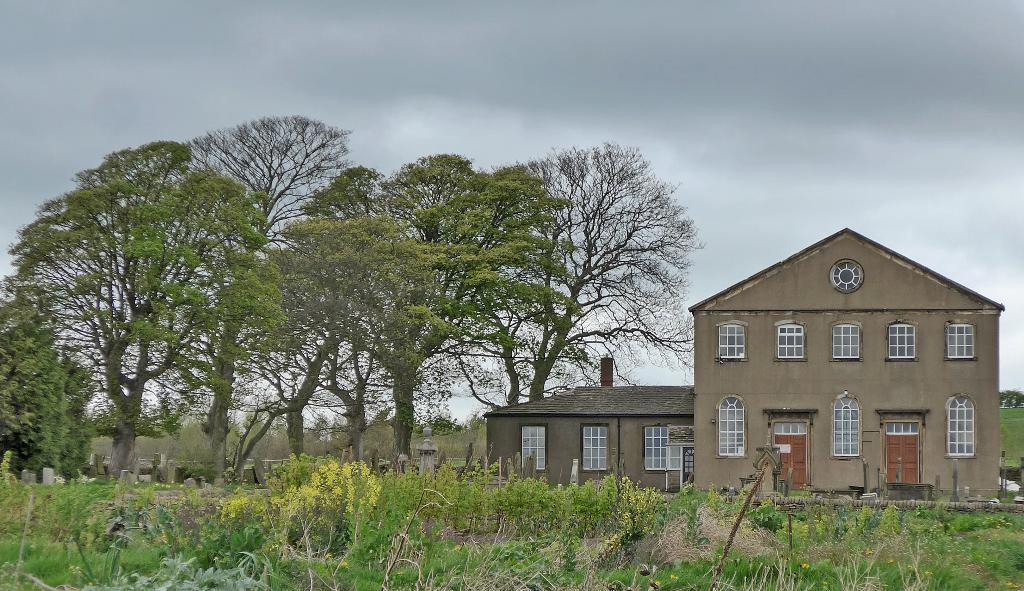What type of structure is present in the image? There is a house in the image. What features can be seen on the house? The house has windows and doors. Can you describe the setting of the image? The image may depict a graveyard. What type of vegetation is present in the image? There are trees and plants in the image. What is visible in the sky in the image? The sky is visible in the image, and there are clouds in the sky. How many boys are playing with the wrist in the image? There are no boys or wrists present in the image. What type of pest can be seen crawling on the plants in the image? There are no pests visible on the plants in the image. 